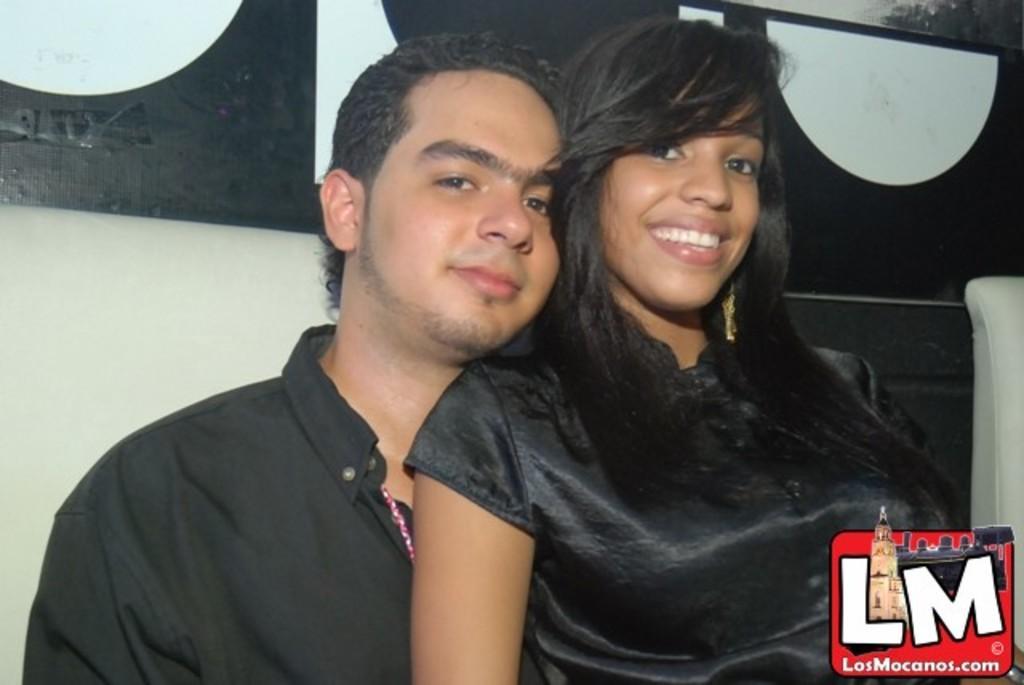How would you summarize this image in a sentence or two? In the center of the image there are two people wearing black color dress. In the background of the image there is black color banner. To the right side bottom of the image there is a logo. 